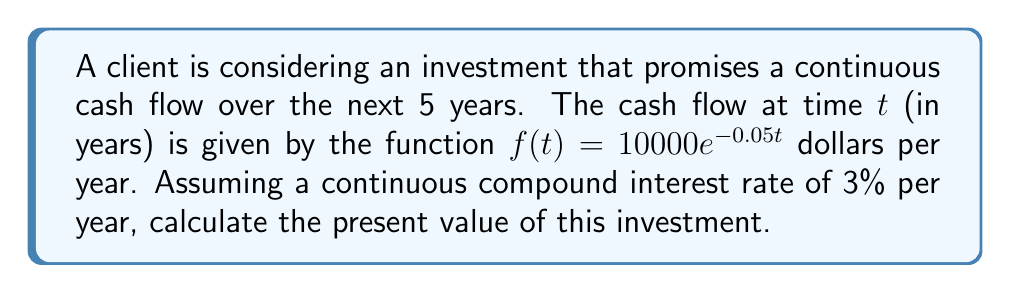Help me with this question. To solve this problem, we need to use the concept of present value and definite integrals. The present value of a continuous cash flow over a period can be calculated using the following steps:

1) The present value of a cash flow $f(t)$ at time $t$ with a continuous compound interest rate $r$ is given by:

   $PV = f(t)e^{-rt}$

2) To find the total present value over the 5-year period, we need to integrate this function from 0 to 5:

   $PV = \int_0^5 f(t)e^{-rt} dt$

3) In this case, $f(t) = 10000e^{-0.05t}$ and $r = 0.03$. Substituting these into our integral:

   $PV = \int_0^5 10000e^{-0.05t}e^{-0.03t} dt$

4) Simplify the exponent:

   $PV = \int_0^5 10000e^{-0.08t} dt$

5) Now we can evaluate the integral:

   $PV = 10000 \left[-\frac{1}{0.08}e^{-0.08t}\right]_0^5$

6) Evaluate the bounds:

   $PV = 10000 \left(-\frac{1}{0.08}e^{-0.08(5)} + \frac{1}{0.08}e^{-0.08(0)}\right)$

7) Simplify:

   $PV = 10000 \left(-\frac{1}{0.08}e^{-0.4} + \frac{1}{0.08}\right)$

8) Calculate the final value:

   $PV = 10000 \left(\frac{1-e^{-0.4}}{0.08}\right) \approx 42,647.34$

Therefore, the present value of the investment is approximately $42,647.34.
Answer: $42,647.34 